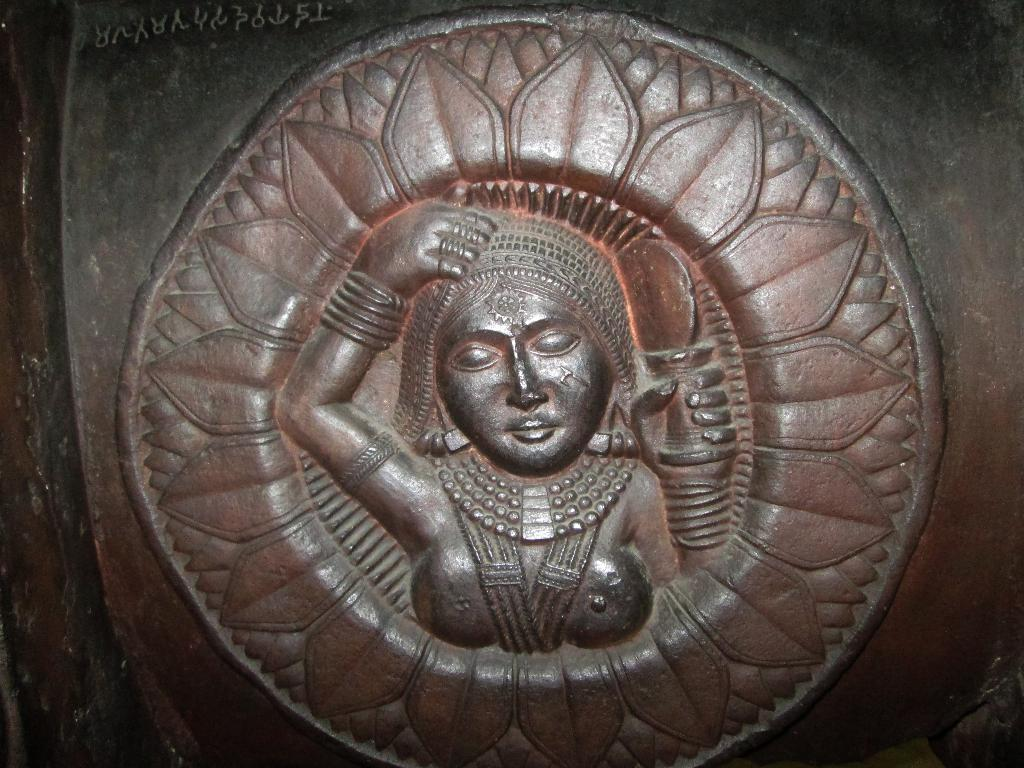What type of art is featured in the image? The image contains carving art. What color of ink is used in the carving art in the image? There is no ink present in the image, as it features carving art, which is typically created by removing material rather than applying ink. 